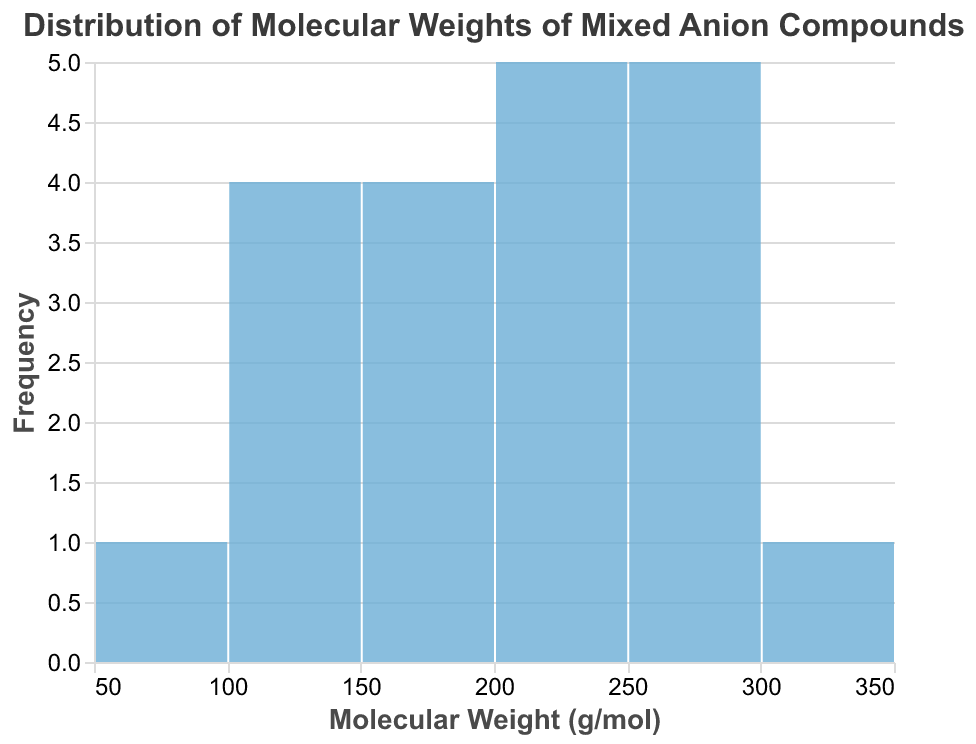What is the title of the histogram? The title of a histogram is usually displayed prominently at the top and provides an overview of the data presented. In this case, the title provided in the code specifies the distribution of molecular weights.
Answer: Distribution of Molecular Weights of Mixed Anion Compounds How many bins are there in the histogram? To count the bins, observe the number of distinct vertical bars on the x-axis, which represent different ranges of molecular weights. The provided code indicates the binning step is set to 50 g/mol.
Answer: 5 Which molecular weight bin has the highest frequency? Identify the tallest bar on the histogram. The x-axis range that corresponds to this bar indicates the molecular weight bin with the highest frequency.
Answer: 150-200 g/mol How many compounds have molecular weights between 250 and 300 g/mol? Count the bar heights within the molecular weight range of 250 to 300 g/mol by looking at the x-axis labels corresponding to this range.
Answer: 4 What's the range of molecular weights presented? The range is determined by subtracting the minimum molecular weight from the maximum molecular weight observed in the histogram.
Answer: 93.75 to 343.26 g/mol Are there more compounds with a molecular weight below 200 g/mol or above 200 g/mol? Compare the total number of compounds in the bins below 200 g/mol with those above. Sum the frequencies in the relevant bins to make the comparison.
Answer: Below 200 g/mol What is the median molecular weight range? To find the median, sort the molecular weights in ascending order and identify the middle value. Look at the histogram and find the bin that contains this middle value.
Answer: 150-200 g/mol How many compounds have molecular weights above 300 g/mol? Locate the bars that represent molecular weights above 300 g/mol on the x-axis and sum their heights to find the total frequency.
Answer: 1 Which bin has the lowest frequency? Identify the shortest bar(s) on the histogram and note the corresponding range on the x-axis. This bin represents the lowest frequency.
Answer: 250-300 g/mol What is the average molecular weight of all compounds? Sum all the molecular weights and divide by the total number of compounds provided in the data.
Answer: (Sum of all molecular weights) / 20 = 197.82 g/mol 